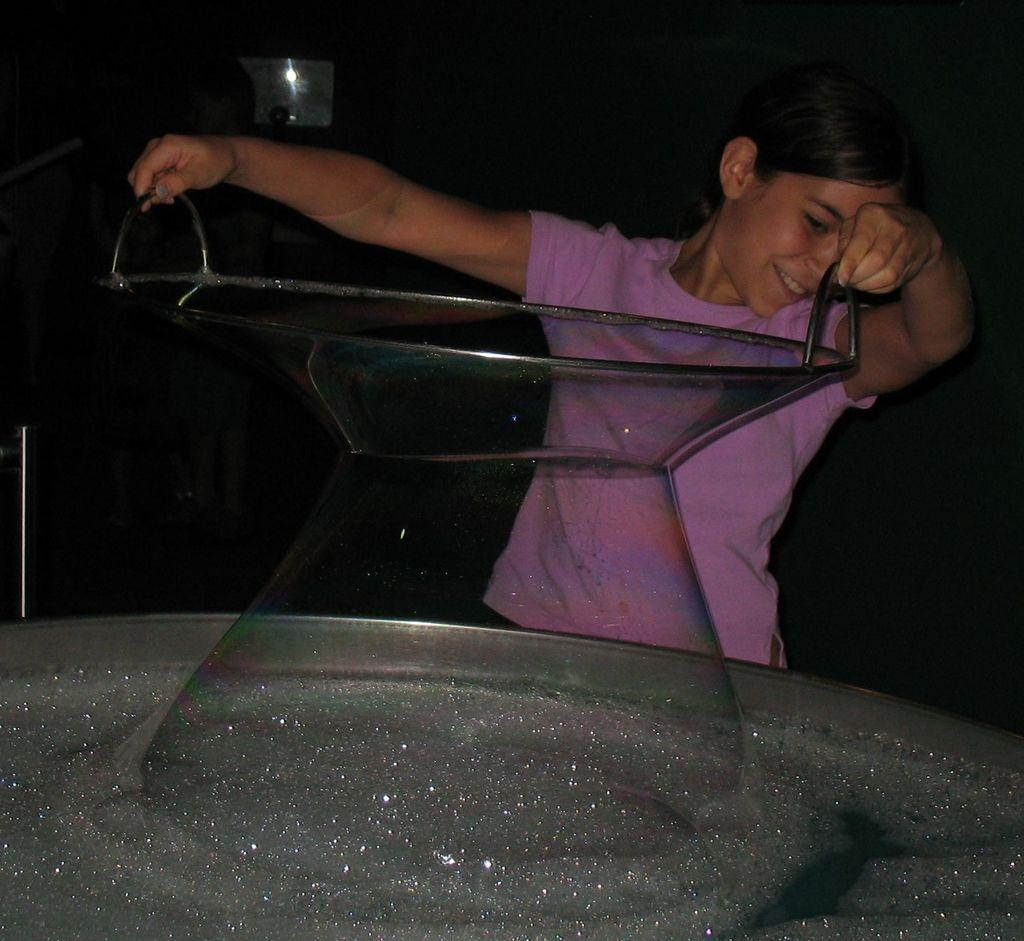Who is the main subject in the image? There is a girl in the image. What is the girl holding in her hands? The girl is holding an object in her hands. What can be seen in the tub in the image? There is foam on the water in the tub. What is visible in the background of the image? The background of the image contains an object, but its nature is unclear. What scientific theory is being proven by the girl in the image? There is no scientific theory being proven by the girl in the image; she is simply holding an object and standing near a tub with foamy water. 